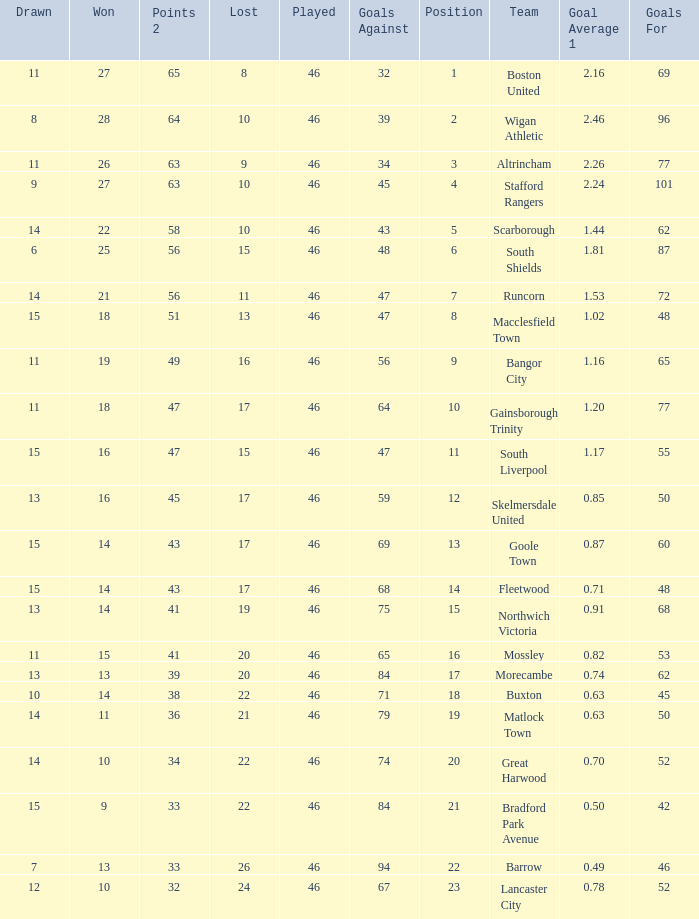How many games did the team who scored 60 goals win? 14.0. 